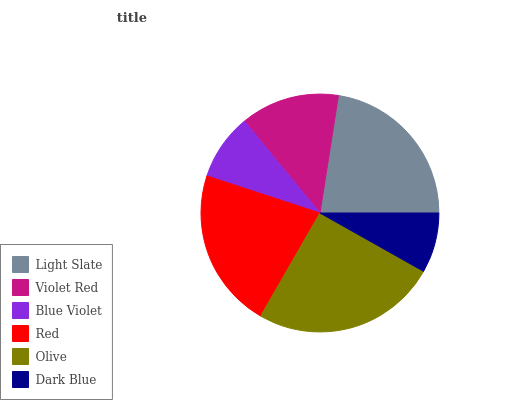Is Dark Blue the minimum?
Answer yes or no. Yes. Is Olive the maximum?
Answer yes or no. Yes. Is Violet Red the minimum?
Answer yes or no. No. Is Violet Red the maximum?
Answer yes or no. No. Is Light Slate greater than Violet Red?
Answer yes or no. Yes. Is Violet Red less than Light Slate?
Answer yes or no. Yes. Is Violet Red greater than Light Slate?
Answer yes or no. No. Is Light Slate less than Violet Red?
Answer yes or no. No. Is Red the high median?
Answer yes or no. Yes. Is Violet Red the low median?
Answer yes or no. Yes. Is Violet Red the high median?
Answer yes or no. No. Is Olive the low median?
Answer yes or no. No. 